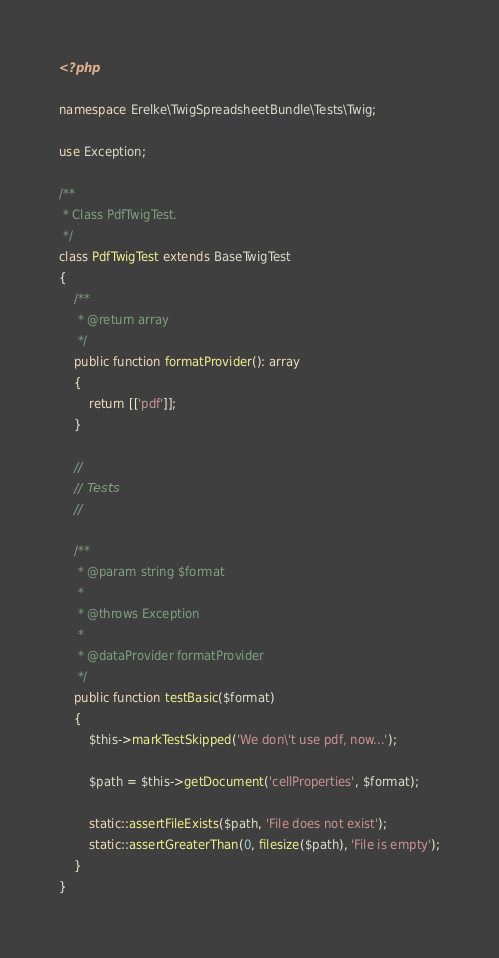<code> <loc_0><loc_0><loc_500><loc_500><_PHP_><?php

namespace Erelke\TwigSpreadsheetBundle\Tests\Twig;

use Exception;

/**
 * Class PdfTwigTest.
 */
class PdfTwigTest extends BaseTwigTest
{
    /**
     * @return array
     */
    public function formatProvider(): array
    {
        return [['pdf']];
    }

    //
    // Tests
    //

    /**
     * @param string $format
     *
     * @throws Exception
     *
     * @dataProvider formatProvider
     */
    public function testBasic($format)
    {
    	$this->markTestSkipped('We don\'t use pdf, now...');

        $path = $this->getDocument('cellProperties', $format);

        static::assertFileExists($path, 'File does not exist');
        static::assertGreaterThan(0, filesize($path), 'File is empty');
    }
}
</code> 